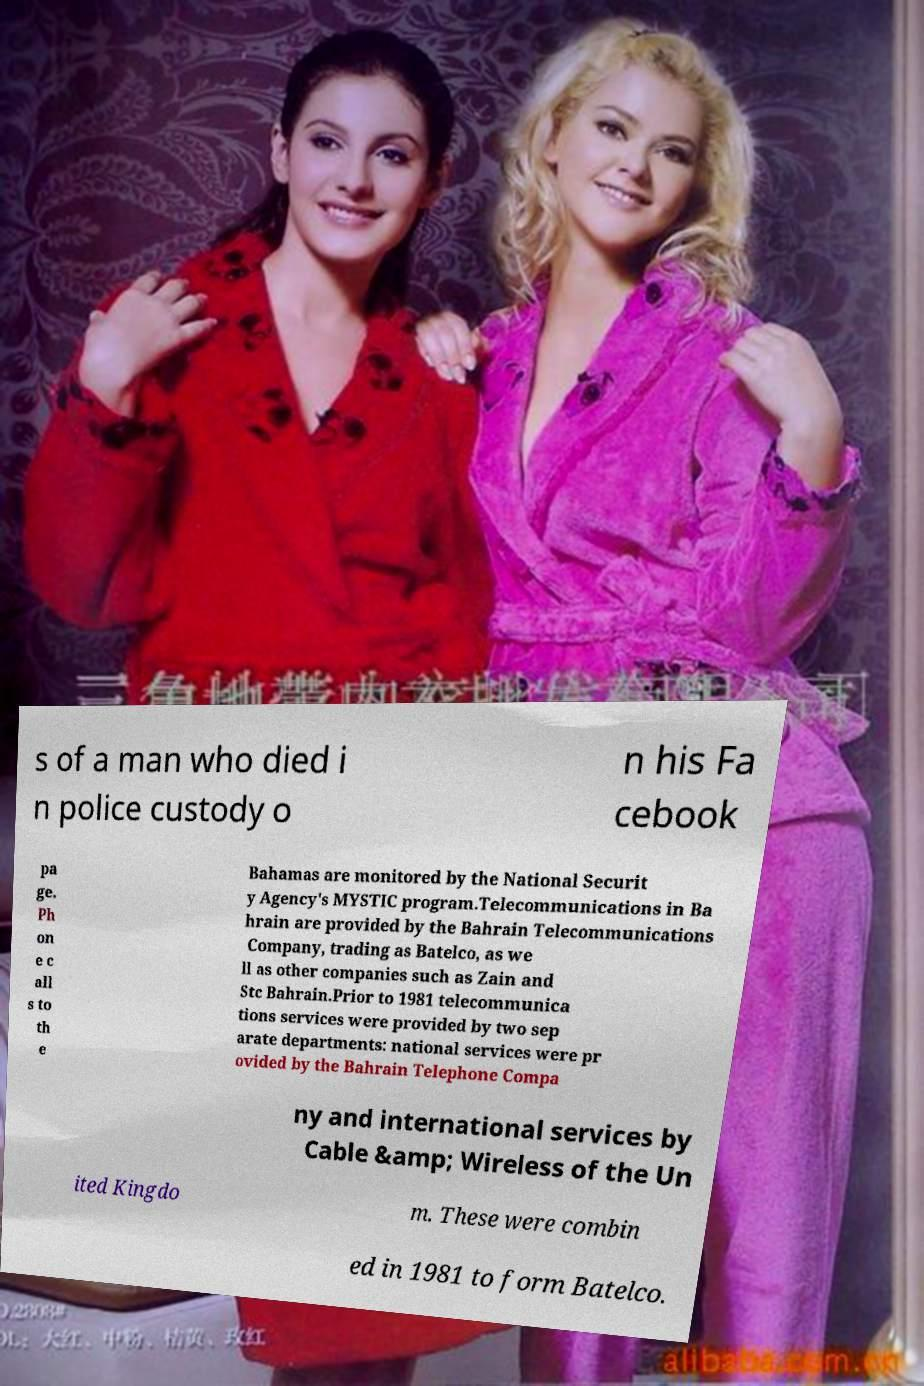Can you accurately transcribe the text from the provided image for me? s of a man who died i n police custody o n his Fa cebook pa ge. Ph on e c all s to th e Bahamas are monitored by the National Securit y Agency's MYSTIC program.Telecommunications in Ba hrain are provided by the Bahrain Telecommunications Company, trading as Batelco, as we ll as other companies such as Zain and Stc Bahrain.Prior to 1981 telecommunica tions services were provided by two sep arate departments: national services were pr ovided by the Bahrain Telephone Compa ny and international services by Cable &amp; Wireless of the Un ited Kingdo m. These were combin ed in 1981 to form Batelco. 